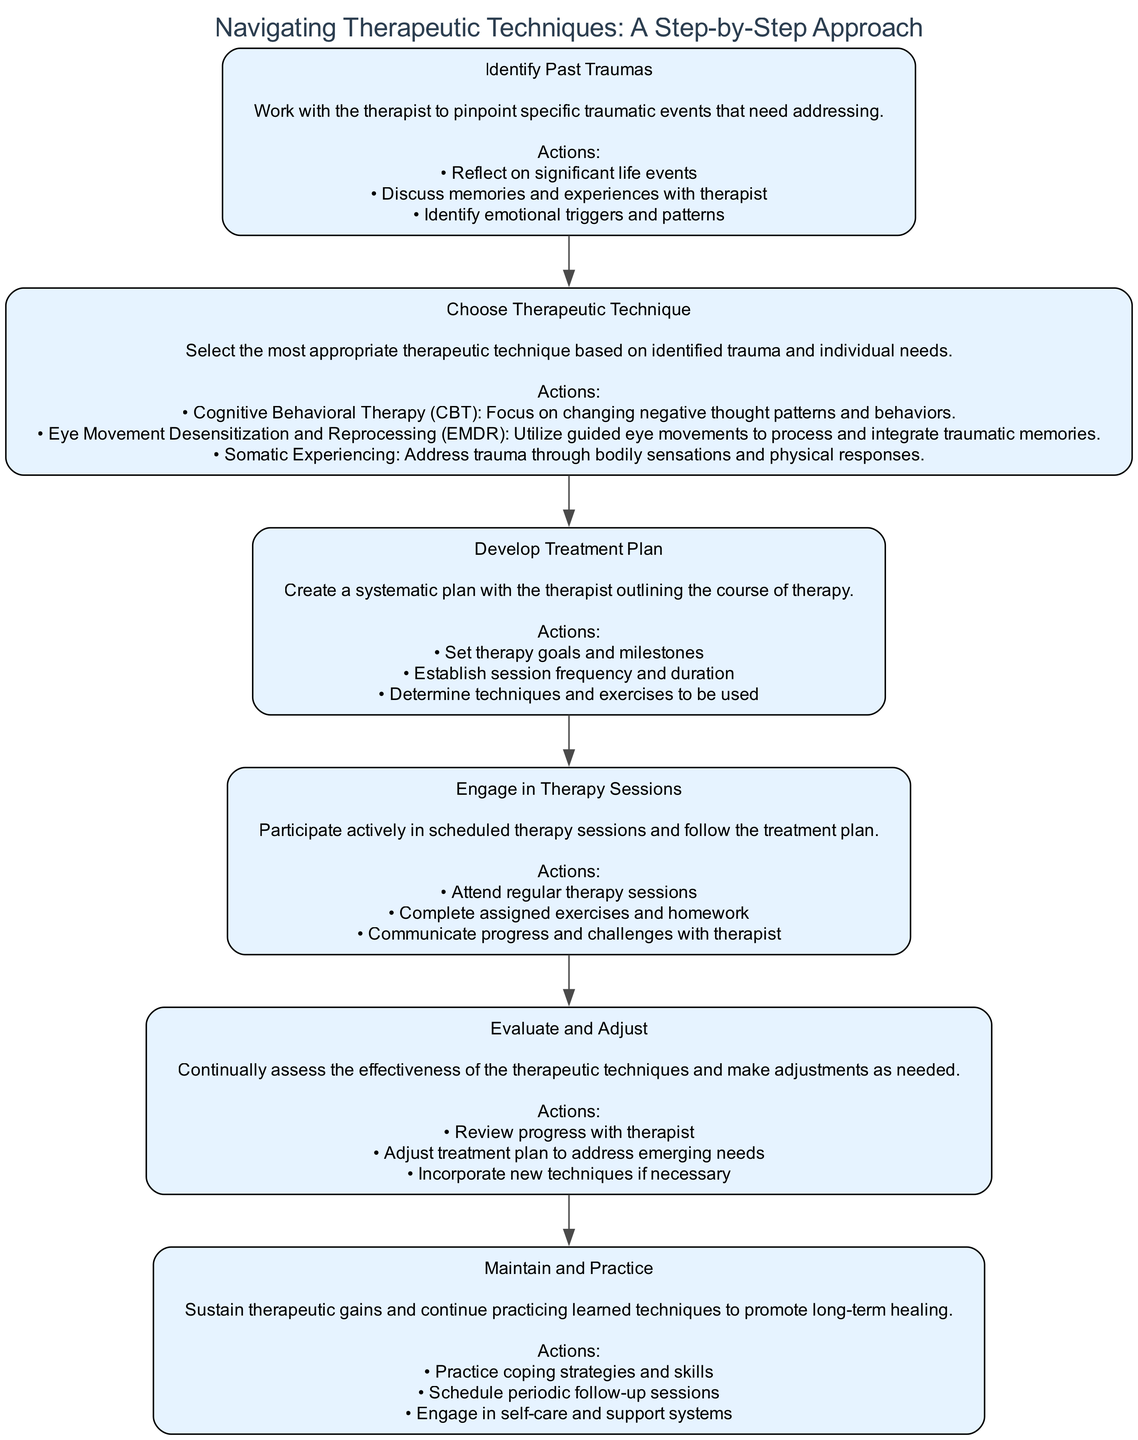What is the first step in the therapeutic process? The first step listed in the diagram is "Identify Past Traumas," which involves working with the therapist to pinpoint specific traumatic events that need addressing.
Answer: Identify Past Traumas How many total steps are in the diagram? The diagram outlines six distinct steps in the therapeutic process, each representing a key phase from identifying traumas to maintaining progress.
Answer: Six What type of therapeutic technique is focused on changing negative thought patterns? Among the listed therapeutic techniques, "Cognitive Behavioral Therapy (CBT)" is specifically aimed at changing negative thought patterns and behaviors.
Answer: Cognitive Behavioral Therapy (CBT) What are the actions involved in step 4? In step 4, "Engage in Therapy Sessions," the actions include attending regular therapy sessions, completing assigned exercises and homework, and communicating progress and challenges with the therapist.
Answer: Attend regular therapy sessions, complete assigned exercises and homework, communicate progress and challenges What is the last step in the therapeutic process? The final step in the diagram is "Maintain and Practice," which focuses on sustaining therapeutic gains and practicing learned techniques for long-term healing.
Answer: Maintain and Practice Which step involves adjusting the treatment plan? The step that involves adjusting the treatment plan is "Evaluate and Adjust," which includes reviewing progress and making changes to address emerging needs.
Answer: Evaluate and Adjust What is the primary purpose of the "Develop Treatment Plan" step? The primary purpose of the "Develop Treatment Plan" step is to create a systematic plan with the therapist that outlines the course of therapy, including setting goals and determining techniques.
Answer: Create a systematic plan with the therapist Which therapeutic technique involves processing traumatic memories through guided eye movements? The technique that utilizes guided eye movements to process traumatic memories is "Eye Movement Desensitization and Reprocessing (EMDR)."
Answer: Eye Movement Desensitization and Reprocessing (EMDR) 